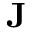<formula> <loc_0><loc_0><loc_500><loc_500>J</formula> 